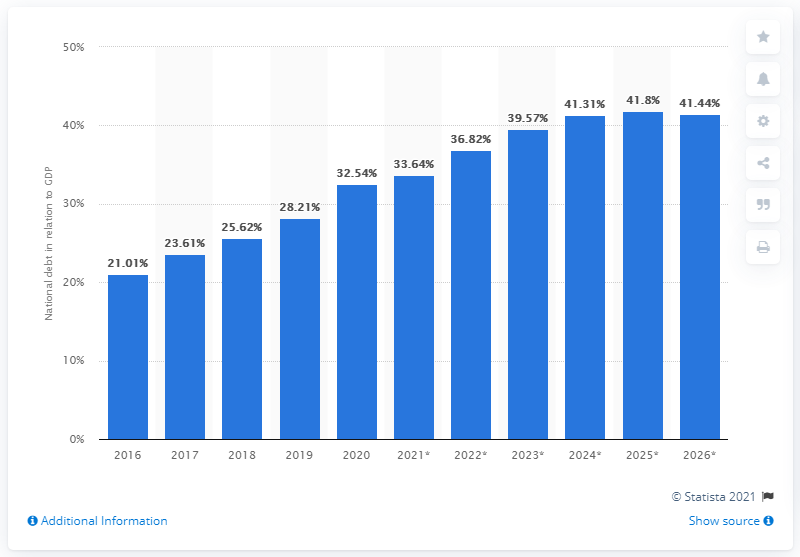Can you tell me how the trend of Chile's national debt as a percentage of GDP changed from 2016 to 2020? Certainly! The bar graph shows a progressive increase in Chile's national debt as a percentage of GDP from 2016 to 2020, starting at 21.0% in 2016 and rising steadily each year to 28.2% by 2020. 